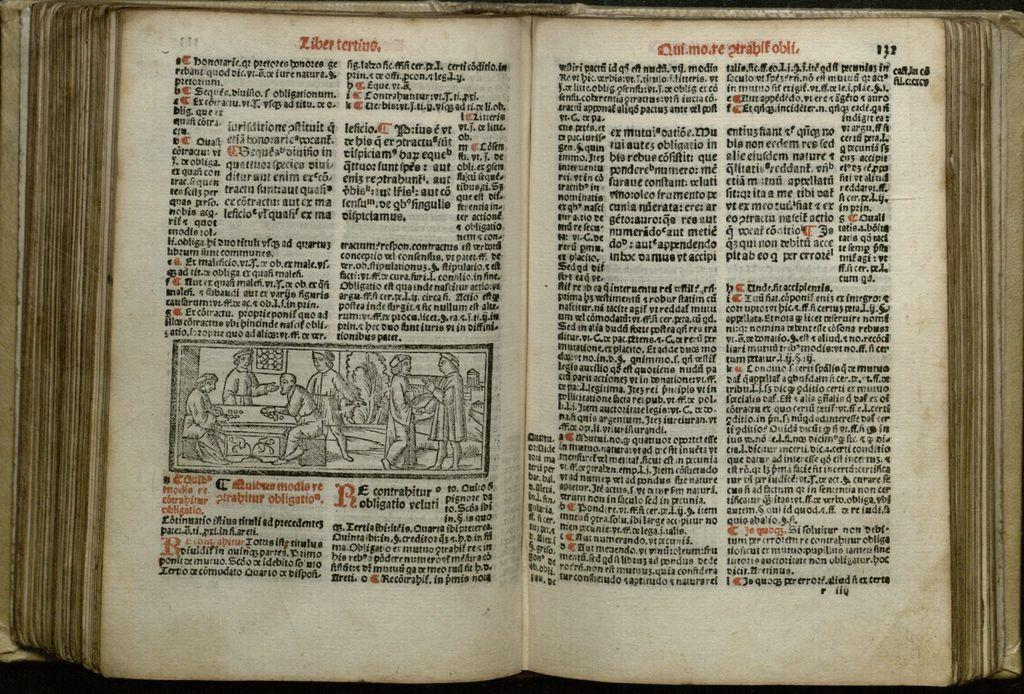<image>
Describe the image concisely. Open book with red words "ziberterine" on the top. 